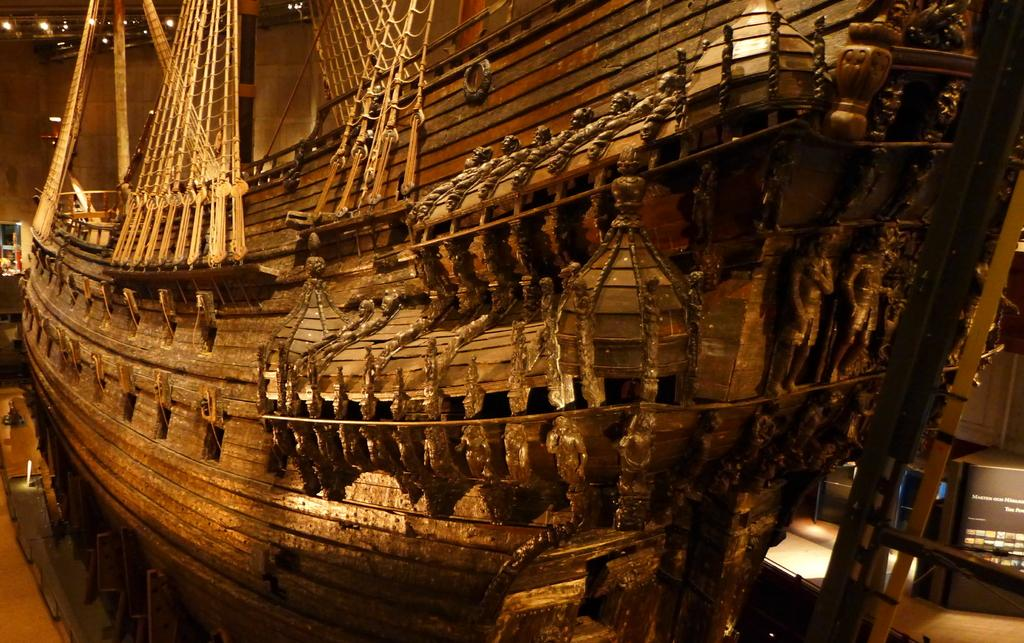What type of vehicle is in the image? There is a wooden ship in the image. What can be seen in the background of the image? There is a wall and lights visible in the background of the image. What type of mailbox is attached to the wooden ship in the image? There is no mailbox present in the image; it features a wooden ship and a background with a wall and lights. 